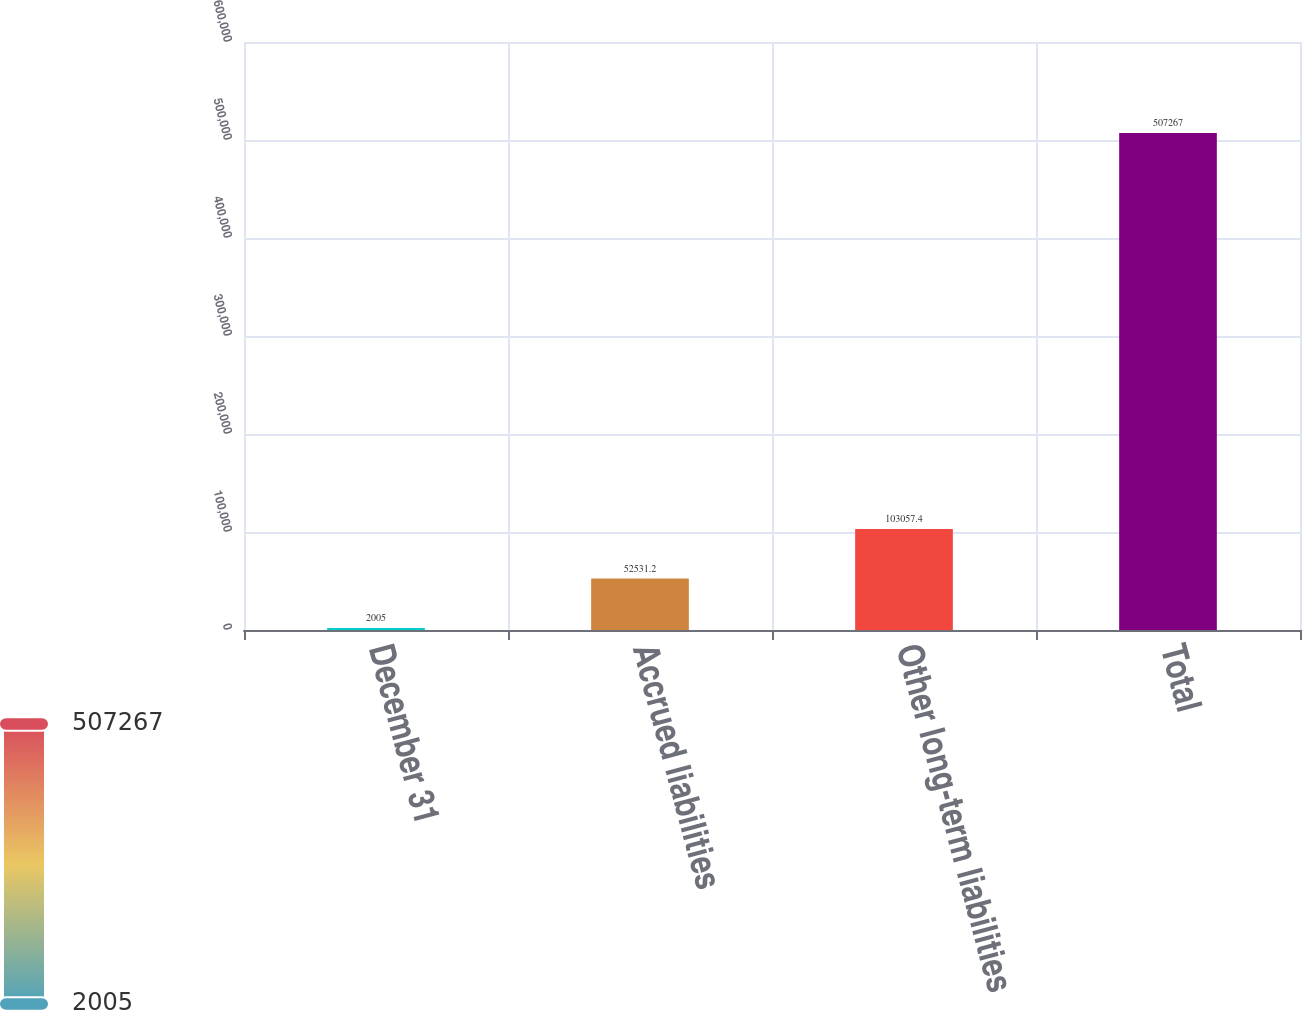Convert chart. <chart><loc_0><loc_0><loc_500><loc_500><bar_chart><fcel>December 31<fcel>Accrued liabilities<fcel>Other long-term liabilities<fcel>Total<nl><fcel>2005<fcel>52531.2<fcel>103057<fcel>507267<nl></chart> 